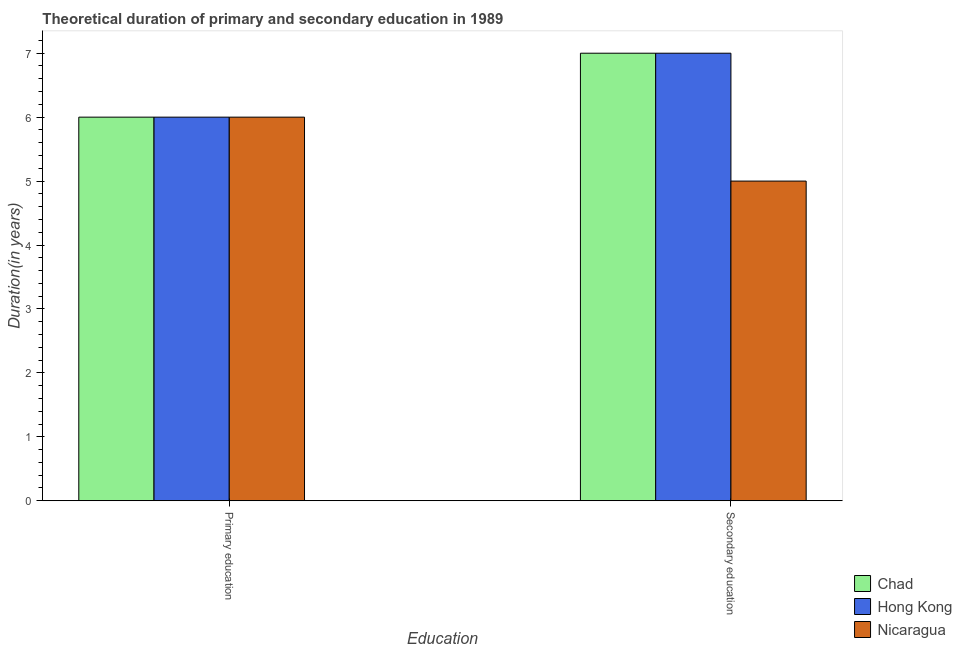How many groups of bars are there?
Provide a short and direct response. 2. Are the number of bars on each tick of the X-axis equal?
Your response must be concise. Yes. How many bars are there on the 1st tick from the left?
Keep it short and to the point. 3. How many bars are there on the 2nd tick from the right?
Offer a terse response. 3. What is the duration of primary education in Hong Kong?
Provide a short and direct response. 6. Across all countries, what is the maximum duration of secondary education?
Offer a very short reply. 7. In which country was the duration of primary education maximum?
Your answer should be very brief. Chad. In which country was the duration of secondary education minimum?
Your answer should be very brief. Nicaragua. What is the total duration of secondary education in the graph?
Give a very brief answer. 19. What is the difference between the duration of primary education in Hong Kong and that in Nicaragua?
Keep it short and to the point. 0. What is the difference between the duration of secondary education in Hong Kong and the duration of primary education in Chad?
Your answer should be compact. 1. What is the average duration of secondary education per country?
Your answer should be compact. 6.33. What is the difference between the duration of primary education and duration of secondary education in Chad?
Your response must be concise. -1. In how many countries, is the duration of secondary education greater than the average duration of secondary education taken over all countries?
Offer a terse response. 2. What does the 2nd bar from the left in Secondary education represents?
Offer a very short reply. Hong Kong. What does the 1st bar from the right in Secondary education represents?
Make the answer very short. Nicaragua. How many bars are there?
Your answer should be compact. 6. Are the values on the major ticks of Y-axis written in scientific E-notation?
Ensure brevity in your answer.  No. Does the graph contain any zero values?
Give a very brief answer. No. Where does the legend appear in the graph?
Provide a succinct answer. Bottom right. How many legend labels are there?
Offer a terse response. 3. What is the title of the graph?
Your response must be concise. Theoretical duration of primary and secondary education in 1989. What is the label or title of the X-axis?
Make the answer very short. Education. What is the label or title of the Y-axis?
Offer a terse response. Duration(in years). What is the Duration(in years) in Chad in Primary education?
Keep it short and to the point. 6. What is the Duration(in years) of Hong Kong in Primary education?
Offer a terse response. 6. What is the Duration(in years) in Chad in Secondary education?
Your response must be concise. 7. What is the Duration(in years) of Nicaragua in Secondary education?
Give a very brief answer. 5. Across all Education, what is the maximum Duration(in years) of Chad?
Offer a terse response. 7. Across all Education, what is the maximum Duration(in years) of Nicaragua?
Give a very brief answer. 6. Across all Education, what is the minimum Duration(in years) in Chad?
Keep it short and to the point. 6. What is the total Duration(in years) of Hong Kong in the graph?
Provide a succinct answer. 13. What is the total Duration(in years) in Nicaragua in the graph?
Make the answer very short. 11. What is the difference between the Duration(in years) in Hong Kong in Primary education and that in Secondary education?
Ensure brevity in your answer.  -1. What is the difference between the Duration(in years) of Chad in Primary education and the Duration(in years) of Hong Kong in Secondary education?
Offer a terse response. -1. What is the difference between the Duration(in years) in Chad in Primary education and the Duration(in years) in Nicaragua in Secondary education?
Your answer should be very brief. 1. What is the difference between the Duration(in years) of Hong Kong in Primary education and the Duration(in years) of Nicaragua in Secondary education?
Provide a short and direct response. 1. What is the average Duration(in years) of Nicaragua per Education?
Make the answer very short. 5.5. What is the difference between the Duration(in years) of Chad and Duration(in years) of Hong Kong in Secondary education?
Give a very brief answer. 0. What is the difference between the Duration(in years) of Chad and Duration(in years) of Nicaragua in Secondary education?
Make the answer very short. 2. What is the difference between the Duration(in years) of Hong Kong and Duration(in years) of Nicaragua in Secondary education?
Keep it short and to the point. 2. What is the ratio of the Duration(in years) in Hong Kong in Primary education to that in Secondary education?
Keep it short and to the point. 0.86. What is the ratio of the Duration(in years) of Nicaragua in Primary education to that in Secondary education?
Offer a very short reply. 1.2. What is the difference between the highest and the second highest Duration(in years) in Hong Kong?
Your response must be concise. 1. What is the difference between the highest and the lowest Duration(in years) in Chad?
Your answer should be compact. 1. What is the difference between the highest and the lowest Duration(in years) of Nicaragua?
Offer a terse response. 1. 